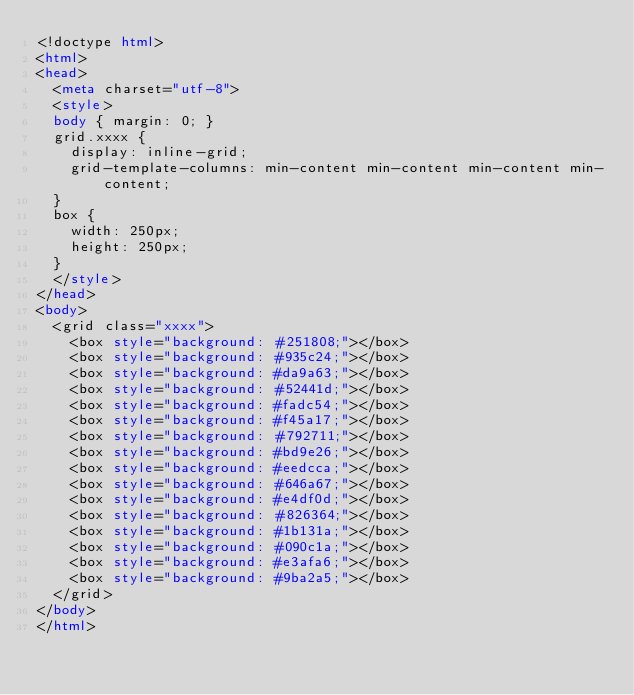<code> <loc_0><loc_0><loc_500><loc_500><_HTML_><!doctype html>
<html>
<head>
  <meta charset="utf-8">
  <style>
  body { margin: 0; }
  grid.xxxx {
    display: inline-grid;
    grid-template-columns: min-content min-content min-content min-content;
  }
  box {
    width: 250px;
    height: 250px;
  }
  </style>
</head>
<body>
  <grid class="xxxx">
    <box style="background: #251808;"></box>
    <box style="background: #935c24;"></box>
    <box style="background: #da9a63;"></box>
    <box style="background: #52441d;"></box>
    <box style="background: #fadc54;"></box>
    <box style="background: #f45a17;"></box>
    <box style="background: #792711;"></box>
    <box style="background: #bd9e26;"></box>
    <box style="background: #eedcca;"></box>
    <box style="background: #646a67;"></box>
    <box style="background: #e4df0d;"></box>
    <box style="background: #826364;"></box>
    <box style="background: #1b131a;"></box>
    <box style="background: #090c1a;"></box>
    <box style="background: #e3afa6;"></box>
    <box style="background: #9ba2a5;"></box>
  </grid>
</body>
</html></code> 